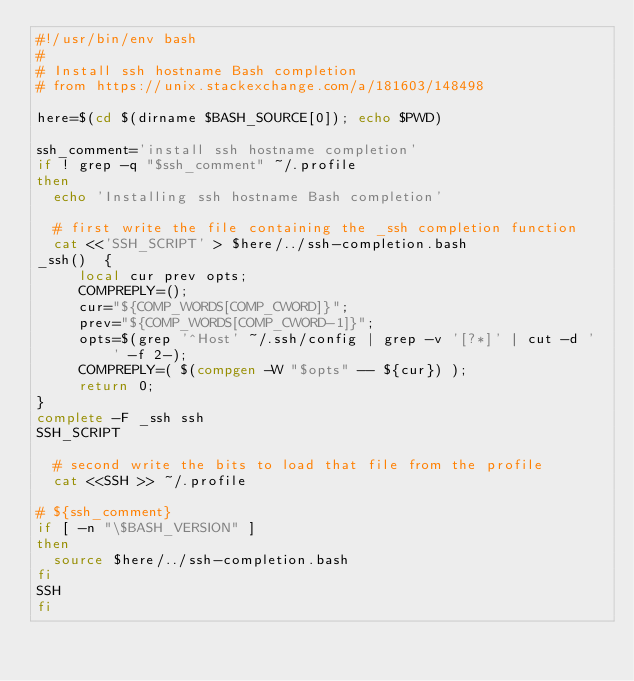Convert code to text. <code><loc_0><loc_0><loc_500><loc_500><_Bash_>#!/usr/bin/env bash
#
# Install ssh hostname Bash completion
# from https://unix.stackexchange.com/a/181603/148498

here=$(cd $(dirname $BASH_SOURCE[0]); echo $PWD)

ssh_comment='install ssh hostname completion'
if ! grep -q "$ssh_comment" ~/.profile
then
  echo 'Installing ssh hostname Bash completion'

  # first write the file containing the _ssh completion function
  cat <<'SSH_SCRIPT' > $here/../ssh-completion.bash
_ssh()  {
     local cur prev opts;
     COMPREPLY=();
     cur="${COMP_WORDS[COMP_CWORD]}";
     prev="${COMP_WORDS[COMP_CWORD-1]}";
     opts=$(grep '^Host' ~/.ssh/config | grep -v '[?*]' | cut -d ' ' -f 2-);
     COMPREPLY=( $(compgen -W "$opts" -- ${cur}) );
     return 0;
}
complete -F _ssh ssh
SSH_SCRIPT

  # second write the bits to load that file from the profile
  cat <<SSH >> ~/.profile

# ${ssh_comment}
if [ -n "\$BASH_VERSION" ]
then
  source $here/../ssh-completion.bash
fi
SSH
fi

</code> 